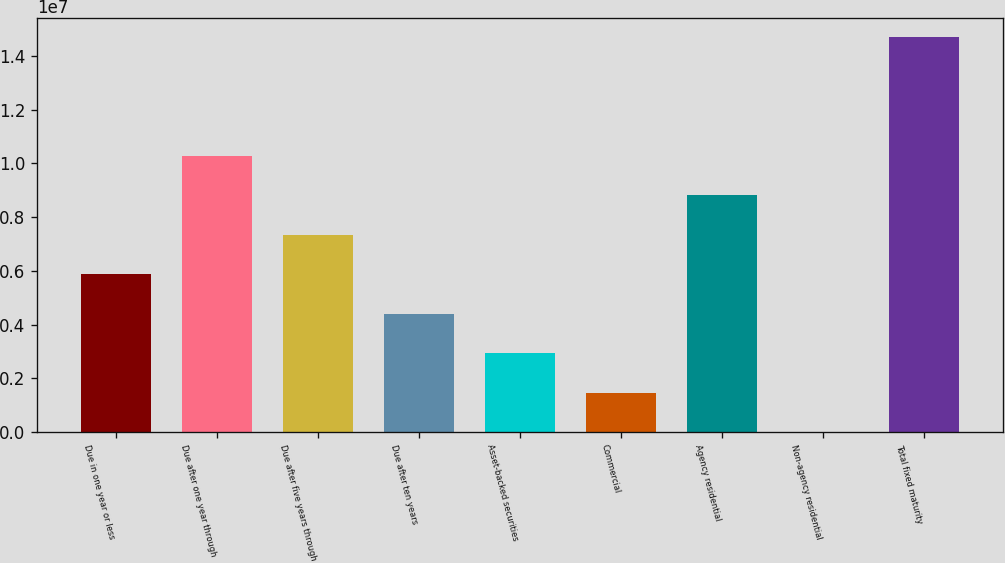<chart> <loc_0><loc_0><loc_500><loc_500><bar_chart><fcel>Due in one year or less<fcel>Due after one year through<fcel>Due after five years through<fcel>Due after ten years<fcel>Asset-backed securities<fcel>Commercial<fcel>Agency residential<fcel>Non-agency residential<fcel>Total fixed maturity<nl><fcel>5.87614e+06<fcel>1.02829e+07<fcel>7.34505e+06<fcel>4.40723e+06<fcel>2.93832e+06<fcel>1.46941e+06<fcel>8.81396e+06<fcel>497<fcel>1.46896e+07<nl></chart> 